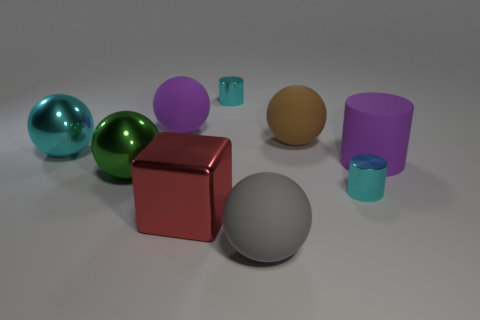Subtract all green balls. How many balls are left? 4 Subtract all red spheres. Subtract all gray cylinders. How many spheres are left? 5 Add 1 big brown objects. How many objects exist? 10 Subtract all cylinders. How many objects are left? 6 Add 8 tiny cyan metal cylinders. How many tiny cyan metal cylinders are left? 10 Add 9 small green shiny spheres. How many small green shiny spheres exist? 9 Subtract 0 red cylinders. How many objects are left? 9 Subtract all big red rubber balls. Subtract all gray matte things. How many objects are left? 8 